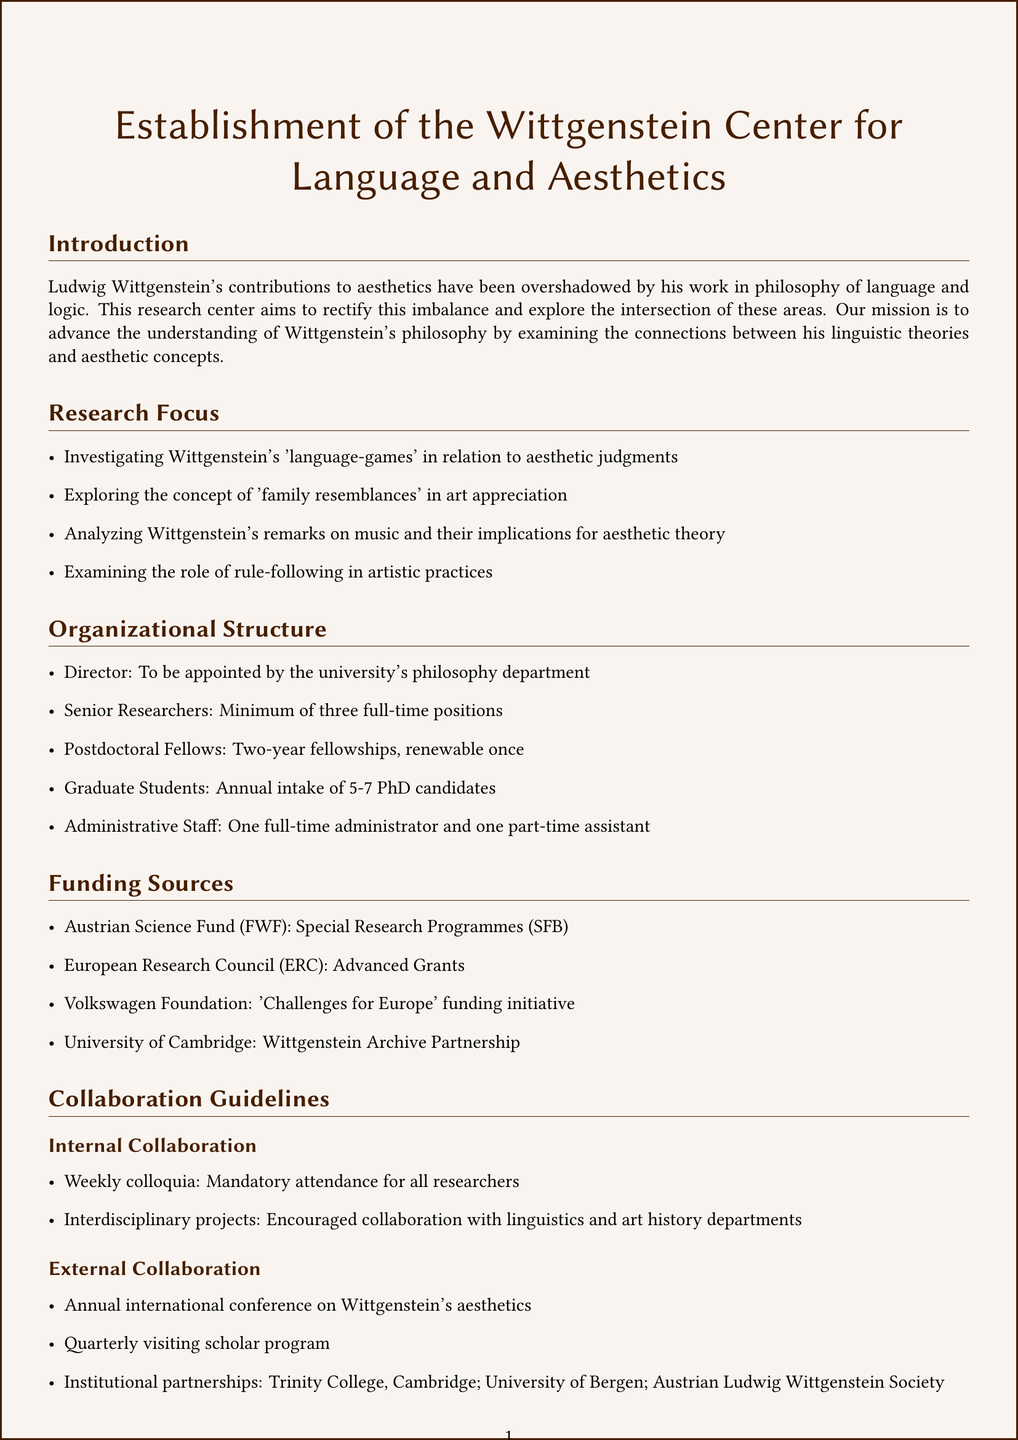what is the title of the policy document? The title of the document is clearly stated at the beginning as "Establishment of the Wittgenstein Center for Language and Aesthetics."
Answer: Establishment of the Wittgenstein Center for Language and Aesthetics who will appoint the director of the research center? The director is to be appointed by the university's philosophy department, indicating the governance of the center.
Answer: university's philosophy department how many senior researchers are required? The document specifies a minimum number of positions required for senior researchers at the center.
Answer: Minimum of three full-time positions which funding source supports long-term research in humanities? The Austrian Science Fund (FWF) is specifically mentioned as supporting long-term research in the humanities.
Answer: Austrian Science Fund (FWF) what is the duration of postdoctoral fellowships? The document states the terms of postdoctoral fellowships offered at the center, specifically their duration and renewability.
Answer: Two-year fellowships, renewable once what kind of projects are encouraged in internal collaboration? Internal collaboration encourages specific types of projects that involve other academic disciplines, as mentioned in the guidelines.
Answer: interdisciplinary projects how often will public lectures be held? The guidelines describe the frequency of public engagement activities, including public lectures, to facilitate community interaction.
Answer: Monthly lectures what is one of the key performance indicators used for evaluation? The document outlines several performance indicators that will be used to evaluate the center's operations and success.
Answer: Number and quality of publications how many graduate students are expected to be admitted annually? The document specifies the annual intake for graduate students, giving insight into the educational opportunities available at the center.
Answer: Annual intake of 5-7 PhD candidates 